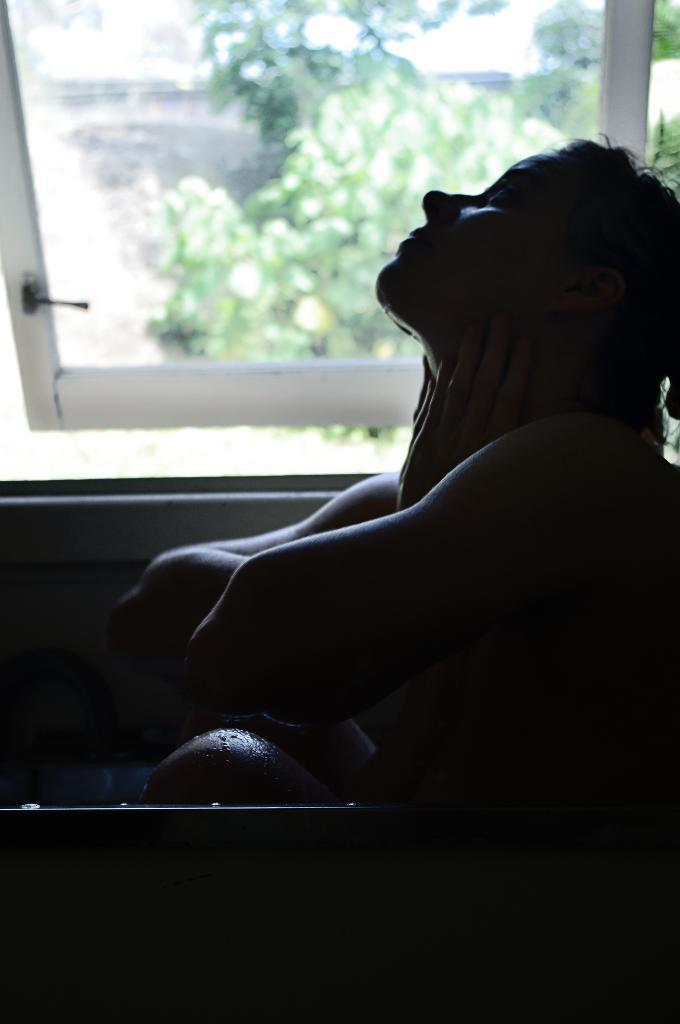Who is present in the image? There is a woman in the image. What can be seen in the background of the image? There is a window in the image, and trees are visible outside the window. What type of humor can be seen on the canvas in the image? There is no canvas or humor present in the image. 